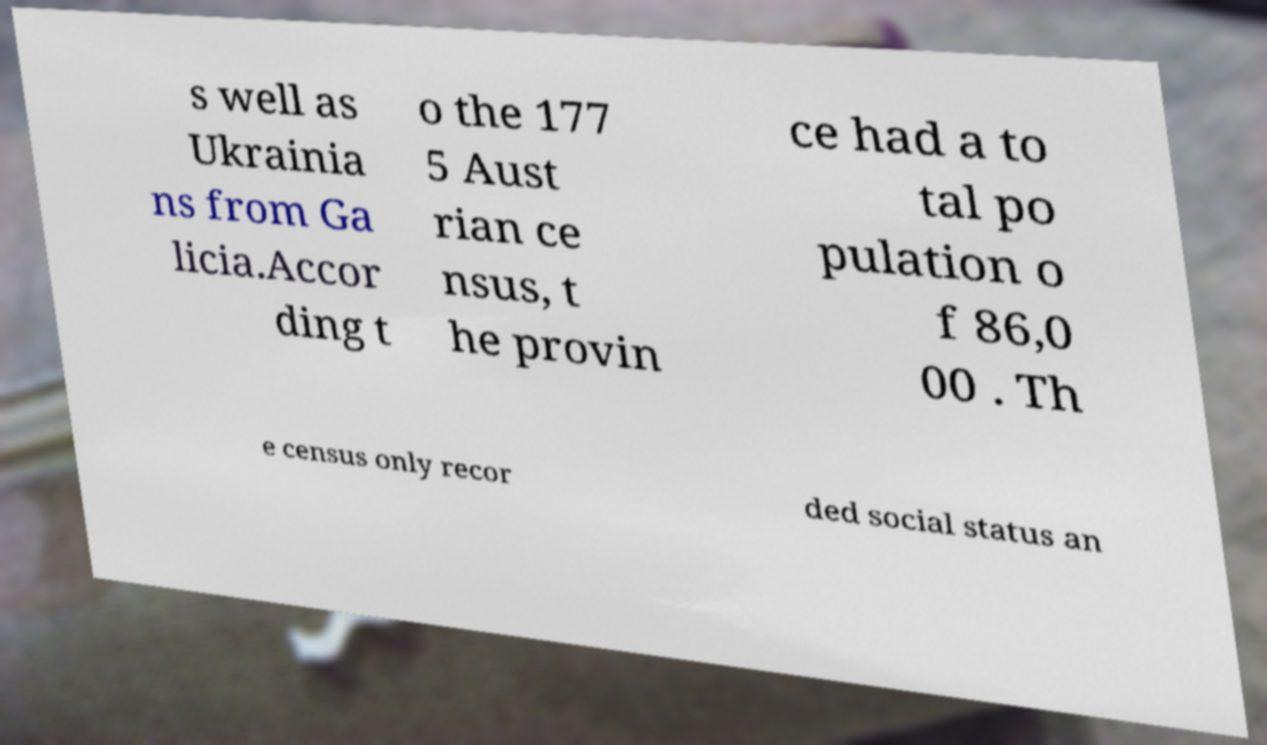Could you extract and type out the text from this image? s well as Ukrainia ns from Ga licia.Accor ding t o the 177 5 Aust rian ce nsus, t he provin ce had a to tal po pulation o f 86,0 00 . Th e census only recor ded social status an 